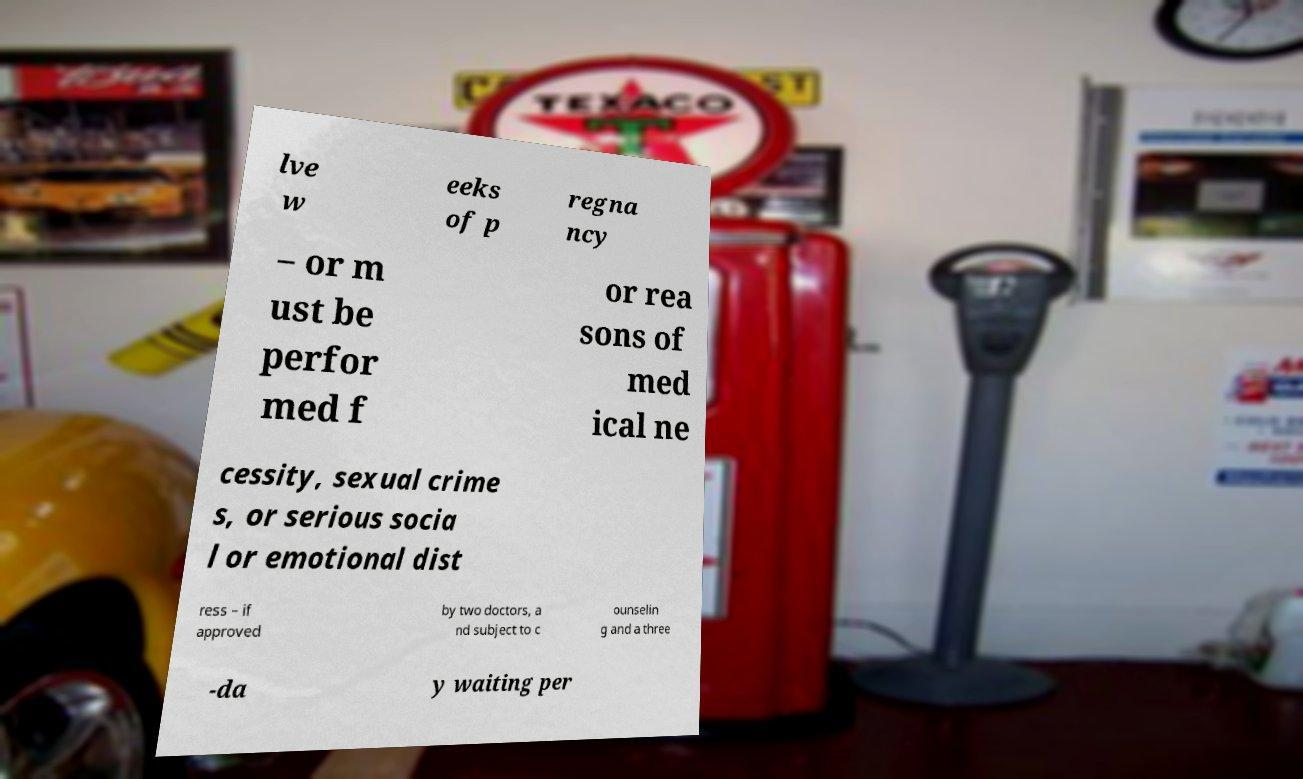Please identify and transcribe the text found in this image. lve w eeks of p regna ncy – or m ust be perfor med f or rea sons of med ical ne cessity, sexual crime s, or serious socia l or emotional dist ress – if approved by two doctors, a nd subject to c ounselin g and a three -da y waiting per 